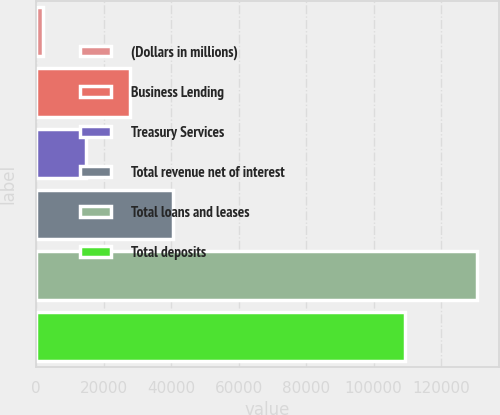Convert chart. <chart><loc_0><loc_0><loc_500><loc_500><bar_chart><fcel>(Dollars in millions)<fcel>Business Lending<fcel>Treasury Services<fcel>Total revenue net of interest<fcel>Total loans and leases<fcel>Total deposits<nl><fcel>2013<fcel>27723<fcel>14868<fcel>40578<fcel>130563<fcel>109225<nl></chart> 